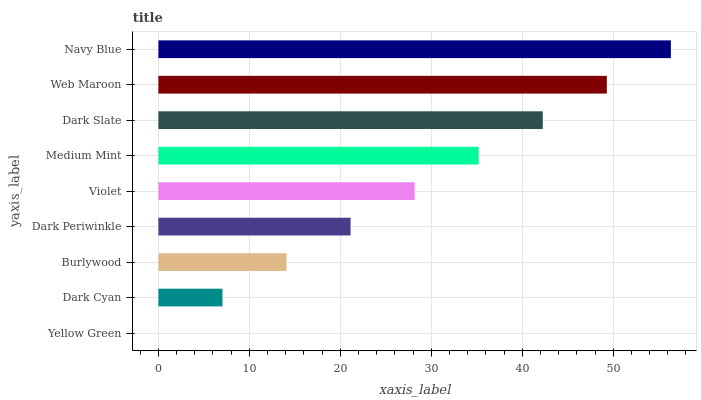Is Yellow Green the minimum?
Answer yes or no. Yes. Is Navy Blue the maximum?
Answer yes or no. Yes. Is Dark Cyan the minimum?
Answer yes or no. No. Is Dark Cyan the maximum?
Answer yes or no. No. Is Dark Cyan greater than Yellow Green?
Answer yes or no. Yes. Is Yellow Green less than Dark Cyan?
Answer yes or no. Yes. Is Yellow Green greater than Dark Cyan?
Answer yes or no. No. Is Dark Cyan less than Yellow Green?
Answer yes or no. No. Is Violet the high median?
Answer yes or no. Yes. Is Violet the low median?
Answer yes or no. Yes. Is Burlywood the high median?
Answer yes or no. No. Is Dark Slate the low median?
Answer yes or no. No. 